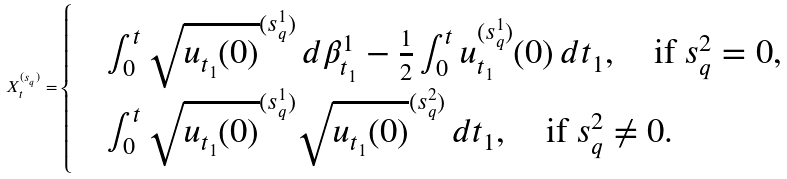<formula> <loc_0><loc_0><loc_500><loc_500>X _ { t } ^ { ( s _ { q } ) } = \begin{cases} & \int _ { 0 } ^ { t } \sqrt { u _ { t _ { 1 } } ( 0 ) } ^ { ( s _ { q } ^ { 1 } ) } \, d \beta _ { t _ { 1 } } ^ { 1 } - \frac { 1 } { 2 } \int _ { 0 } ^ { t } u _ { t _ { 1 } } ^ { ( s _ { q } ^ { 1 } ) } ( 0 ) \, d t _ { 1 } , \quad \text {if } s _ { q } ^ { 2 } = 0 , \\ & \int _ { 0 } ^ { t } \sqrt { u _ { t _ { 1 } } ( 0 ) } ^ { ( s _ { q } ^ { 1 } ) } \sqrt { u _ { t _ { 1 } } ( 0 ) } ^ { ( s _ { q } ^ { 2 } ) } \, d t _ { 1 } , \quad \text {if } s _ { q } ^ { 2 } \neq 0 . \end{cases}</formula> 